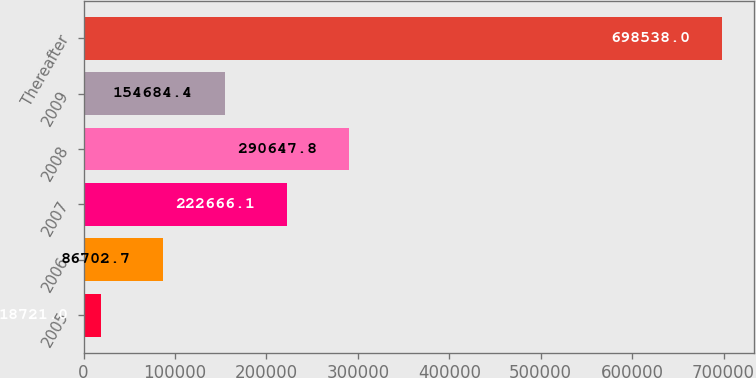Convert chart. <chart><loc_0><loc_0><loc_500><loc_500><bar_chart><fcel>2005<fcel>2006<fcel>2007<fcel>2008<fcel>2009<fcel>Thereafter<nl><fcel>18721<fcel>86702.7<fcel>222666<fcel>290648<fcel>154684<fcel>698538<nl></chart> 